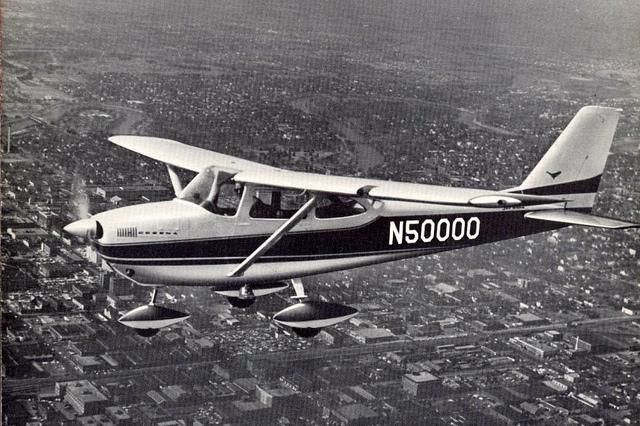Where is the plane?
Concise answer only. In sky. Is this military?
Answer briefly. No. Is this a black and white photo?
Concise answer only. Yes. What number does this plane have on its side?
Be succinct. 50000. 